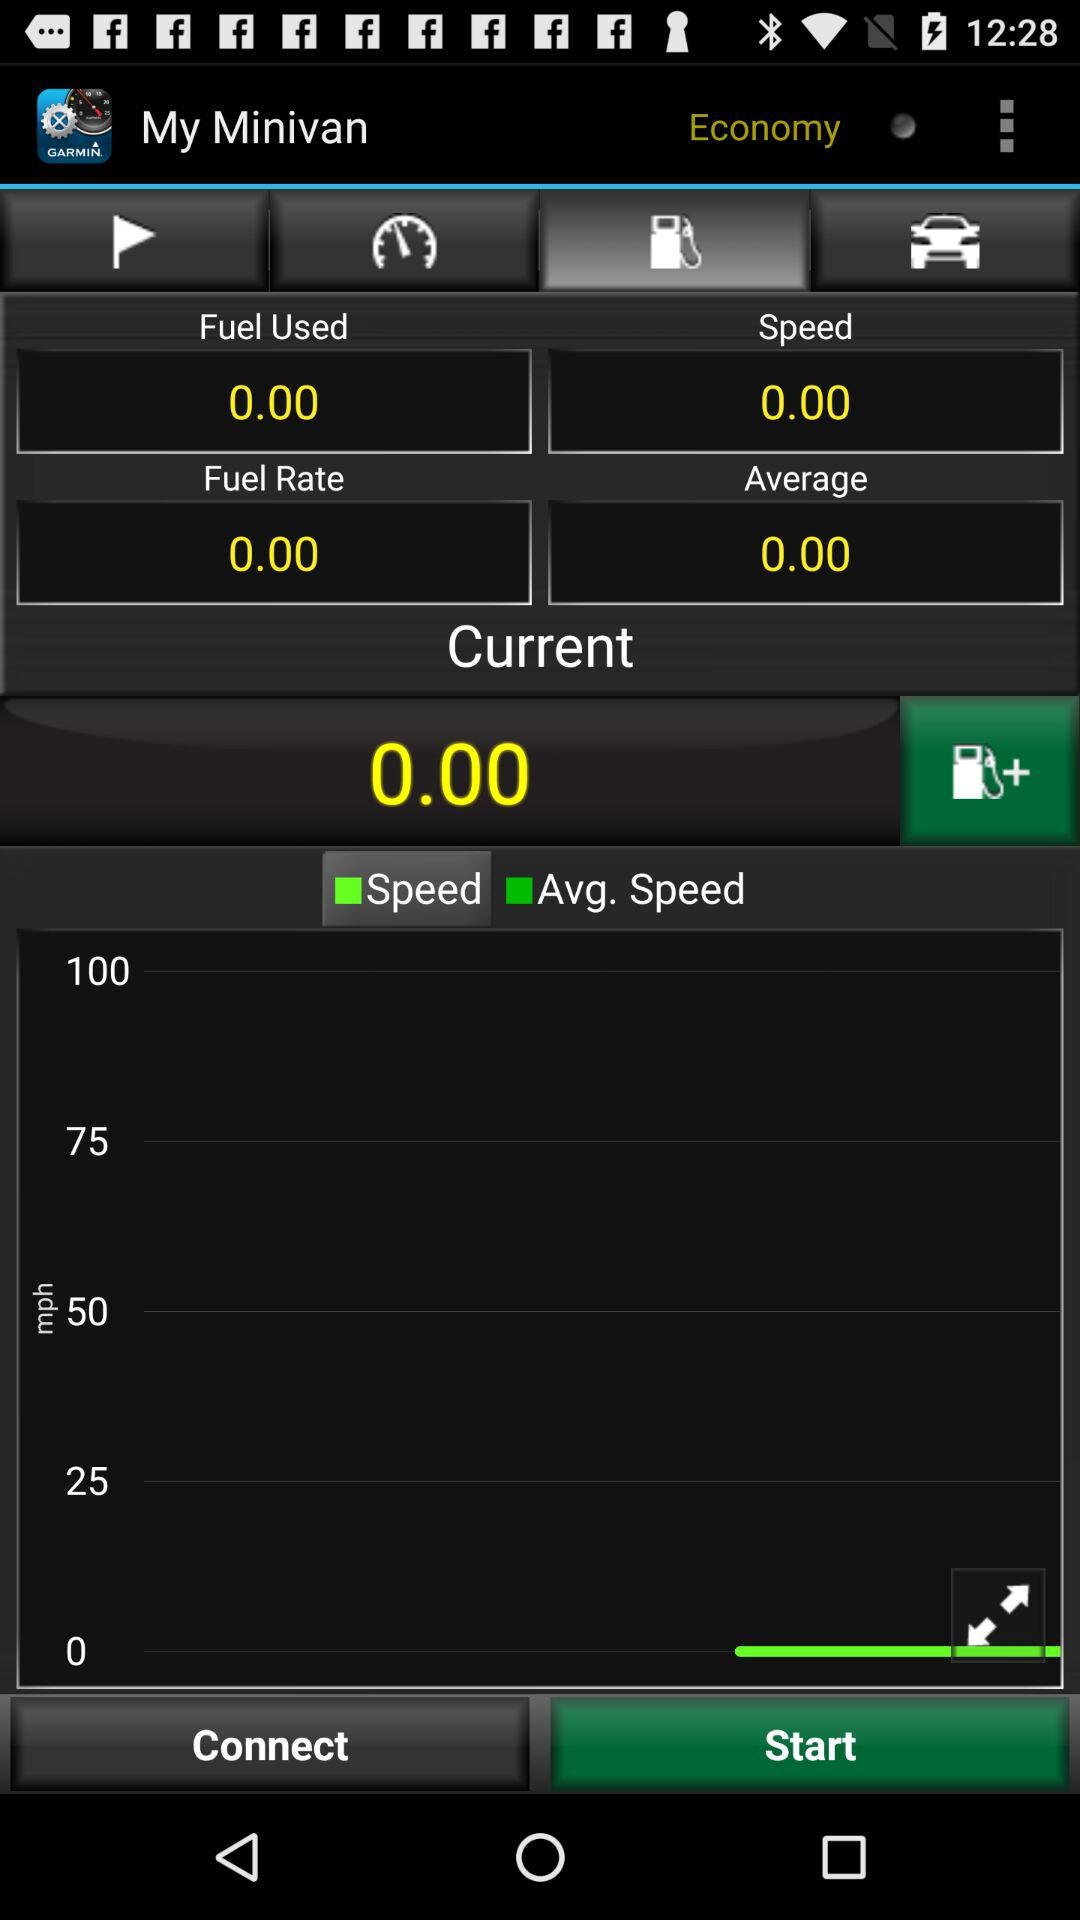What is the fuel rate? The fuel rate is 0.00. 